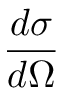Convert formula to latex. <formula><loc_0><loc_0><loc_500><loc_500>\frac { d \sigma } { d \Omega }</formula> 